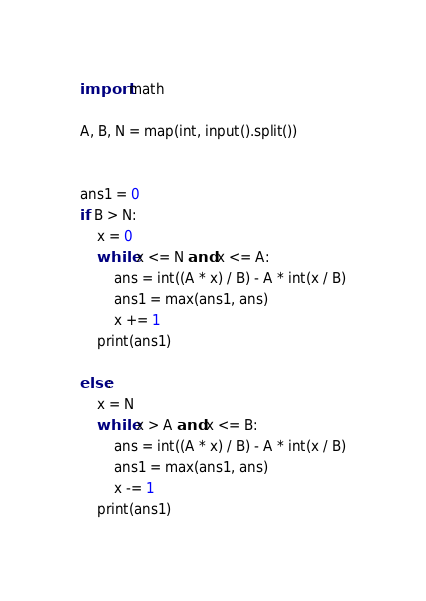<code> <loc_0><loc_0><loc_500><loc_500><_Python_>import math

A, B, N = map(int, input().split())


ans1 = 0
if B > N:
    x = 0
    while x <= N and x <= A:
        ans = int((A * x) / B) - A * int(x / B)
        ans1 = max(ans1, ans)
        x += 1
    print(ans1)

else:
    x = N
    while x > A and x <= B:
        ans = int((A * x) / B) - A * int(x / B)
        ans1 = max(ans1, ans)
        x -= 1
    print(ans1)
</code> 